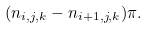Convert formula to latex. <formula><loc_0><loc_0><loc_500><loc_500>( n _ { i , j , k } - n _ { i + 1 , j , k } ) \pi .</formula> 